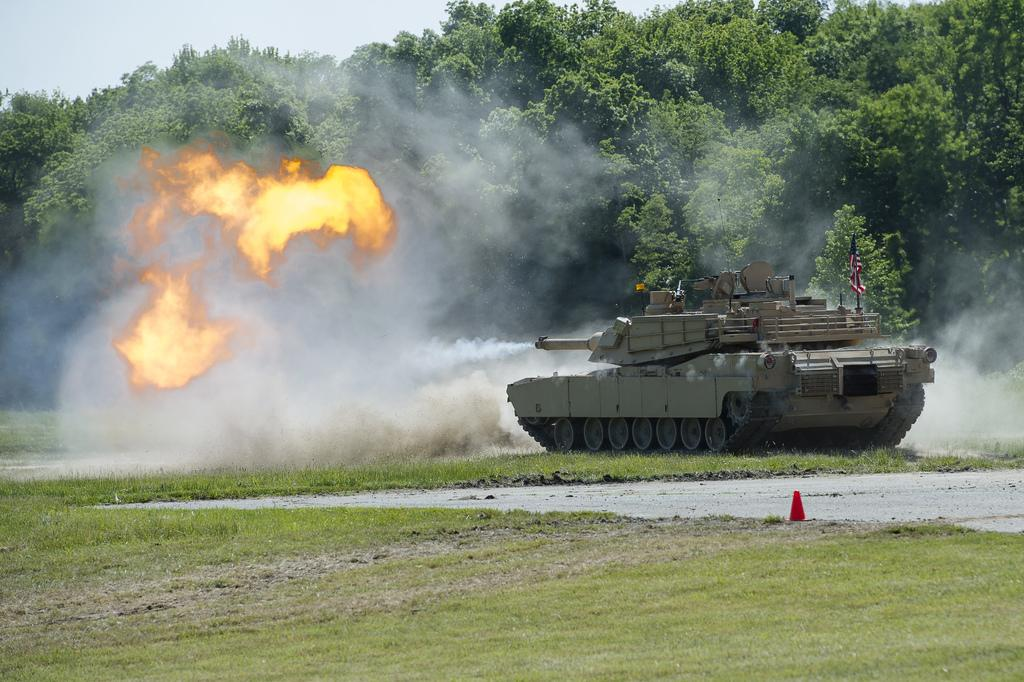What type of vegetation can be seen in the image? There is grass in the image. What type of vehicle is present in the image? There is a tank in the image. What is the result of the fire in the image? Smoke is visible in the image. What is the source of the fire in the image? Fire is present in the image. What type of natural structures are in the image? There are trees in the image. What type of symbol is present in the image? There is a flag in the image. What color stands out in the image? There is a red color thing in the image. What can be seen in the background of the image? The sky is visible in the background of the image. What type of hour is depicted on the tank in the image? There is no hour depicted on the tank in the image. What type of legal advice is the lawyer providing in the image? There is no lawyer present in the image. What type of button is attached to the red color thing in the image? There is no button present on the red color thing in the image. 